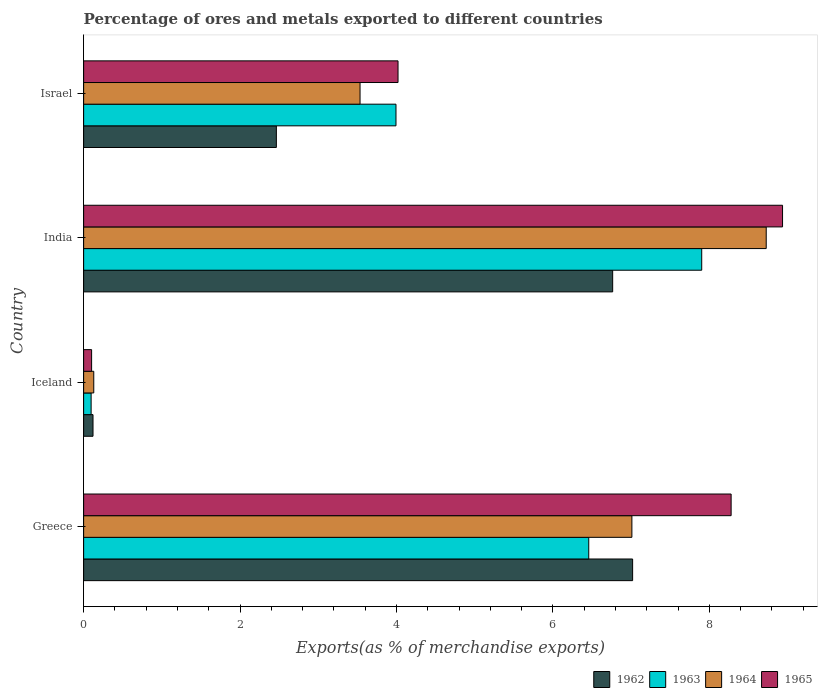Are the number of bars per tick equal to the number of legend labels?
Your answer should be very brief. Yes. Are the number of bars on each tick of the Y-axis equal?
Make the answer very short. Yes. What is the label of the 2nd group of bars from the top?
Offer a terse response. India. What is the percentage of exports to different countries in 1964 in Greece?
Give a very brief answer. 7.01. Across all countries, what is the maximum percentage of exports to different countries in 1962?
Your answer should be compact. 7.02. Across all countries, what is the minimum percentage of exports to different countries in 1964?
Keep it short and to the point. 0.13. In which country was the percentage of exports to different countries in 1962 maximum?
Offer a terse response. Greece. In which country was the percentage of exports to different countries in 1963 minimum?
Give a very brief answer. Iceland. What is the total percentage of exports to different countries in 1962 in the graph?
Give a very brief answer. 16.37. What is the difference between the percentage of exports to different countries in 1962 in Iceland and that in India?
Provide a short and direct response. -6.64. What is the difference between the percentage of exports to different countries in 1965 in India and the percentage of exports to different countries in 1964 in Greece?
Provide a short and direct response. 1.93. What is the average percentage of exports to different countries in 1964 per country?
Offer a terse response. 4.85. What is the difference between the percentage of exports to different countries in 1965 and percentage of exports to different countries in 1962 in Iceland?
Offer a terse response. -0.02. In how many countries, is the percentage of exports to different countries in 1964 greater than 5.6 %?
Keep it short and to the point. 2. What is the ratio of the percentage of exports to different countries in 1962 in India to that in Israel?
Your answer should be very brief. 2.75. Is the percentage of exports to different countries in 1962 in Iceland less than that in India?
Your answer should be compact. Yes. What is the difference between the highest and the second highest percentage of exports to different countries in 1964?
Ensure brevity in your answer.  1.72. What is the difference between the highest and the lowest percentage of exports to different countries in 1963?
Keep it short and to the point. 7.81. In how many countries, is the percentage of exports to different countries in 1965 greater than the average percentage of exports to different countries in 1965 taken over all countries?
Your answer should be very brief. 2. Is the sum of the percentage of exports to different countries in 1962 in Iceland and Israel greater than the maximum percentage of exports to different countries in 1963 across all countries?
Offer a terse response. No. Is it the case that in every country, the sum of the percentage of exports to different countries in 1962 and percentage of exports to different countries in 1963 is greater than the sum of percentage of exports to different countries in 1965 and percentage of exports to different countries in 1964?
Provide a succinct answer. No. What does the 4th bar from the top in Iceland represents?
Ensure brevity in your answer.  1962. What does the 4th bar from the bottom in Greece represents?
Your response must be concise. 1965. Is it the case that in every country, the sum of the percentage of exports to different countries in 1965 and percentage of exports to different countries in 1962 is greater than the percentage of exports to different countries in 1963?
Your answer should be very brief. Yes. Are all the bars in the graph horizontal?
Offer a very short reply. Yes. How many countries are there in the graph?
Keep it short and to the point. 4. What is the difference between two consecutive major ticks on the X-axis?
Your answer should be compact. 2. Does the graph contain any zero values?
Offer a terse response. No. Where does the legend appear in the graph?
Provide a short and direct response. Bottom right. How many legend labels are there?
Make the answer very short. 4. What is the title of the graph?
Your answer should be very brief. Percentage of ores and metals exported to different countries. What is the label or title of the X-axis?
Give a very brief answer. Exports(as % of merchandise exports). What is the Exports(as % of merchandise exports) of 1962 in Greece?
Offer a terse response. 7.02. What is the Exports(as % of merchandise exports) in 1963 in Greece?
Ensure brevity in your answer.  6.46. What is the Exports(as % of merchandise exports) in 1964 in Greece?
Your answer should be very brief. 7.01. What is the Exports(as % of merchandise exports) of 1965 in Greece?
Provide a succinct answer. 8.28. What is the Exports(as % of merchandise exports) of 1962 in Iceland?
Make the answer very short. 0.12. What is the Exports(as % of merchandise exports) in 1963 in Iceland?
Your answer should be very brief. 0.1. What is the Exports(as % of merchandise exports) in 1964 in Iceland?
Keep it short and to the point. 0.13. What is the Exports(as % of merchandise exports) of 1965 in Iceland?
Offer a terse response. 0.1. What is the Exports(as % of merchandise exports) of 1962 in India?
Make the answer very short. 6.76. What is the Exports(as % of merchandise exports) of 1963 in India?
Make the answer very short. 7.9. What is the Exports(as % of merchandise exports) of 1964 in India?
Your response must be concise. 8.73. What is the Exports(as % of merchandise exports) in 1965 in India?
Your answer should be compact. 8.94. What is the Exports(as % of merchandise exports) of 1962 in Israel?
Provide a succinct answer. 2.46. What is the Exports(as % of merchandise exports) in 1963 in Israel?
Make the answer very short. 3.99. What is the Exports(as % of merchandise exports) in 1964 in Israel?
Your answer should be compact. 3.53. What is the Exports(as % of merchandise exports) of 1965 in Israel?
Your response must be concise. 4.02. Across all countries, what is the maximum Exports(as % of merchandise exports) of 1962?
Ensure brevity in your answer.  7.02. Across all countries, what is the maximum Exports(as % of merchandise exports) of 1963?
Your answer should be compact. 7.9. Across all countries, what is the maximum Exports(as % of merchandise exports) in 1964?
Offer a terse response. 8.73. Across all countries, what is the maximum Exports(as % of merchandise exports) in 1965?
Provide a short and direct response. 8.94. Across all countries, what is the minimum Exports(as % of merchandise exports) in 1962?
Make the answer very short. 0.12. Across all countries, what is the minimum Exports(as % of merchandise exports) in 1963?
Provide a succinct answer. 0.1. Across all countries, what is the minimum Exports(as % of merchandise exports) in 1964?
Your response must be concise. 0.13. Across all countries, what is the minimum Exports(as % of merchandise exports) of 1965?
Provide a succinct answer. 0.1. What is the total Exports(as % of merchandise exports) in 1962 in the graph?
Ensure brevity in your answer.  16.37. What is the total Exports(as % of merchandise exports) in 1963 in the graph?
Ensure brevity in your answer.  18.45. What is the total Exports(as % of merchandise exports) in 1964 in the graph?
Ensure brevity in your answer.  19.4. What is the total Exports(as % of merchandise exports) of 1965 in the graph?
Provide a succinct answer. 21.34. What is the difference between the Exports(as % of merchandise exports) of 1962 in Greece and that in Iceland?
Give a very brief answer. 6.9. What is the difference between the Exports(as % of merchandise exports) of 1963 in Greece and that in Iceland?
Ensure brevity in your answer.  6.36. What is the difference between the Exports(as % of merchandise exports) in 1964 in Greece and that in Iceland?
Provide a short and direct response. 6.88. What is the difference between the Exports(as % of merchandise exports) of 1965 in Greece and that in Iceland?
Offer a terse response. 8.18. What is the difference between the Exports(as % of merchandise exports) of 1962 in Greece and that in India?
Keep it short and to the point. 0.26. What is the difference between the Exports(as % of merchandise exports) of 1963 in Greece and that in India?
Your response must be concise. -1.44. What is the difference between the Exports(as % of merchandise exports) in 1964 in Greece and that in India?
Keep it short and to the point. -1.72. What is the difference between the Exports(as % of merchandise exports) of 1965 in Greece and that in India?
Make the answer very short. -0.66. What is the difference between the Exports(as % of merchandise exports) of 1962 in Greece and that in Israel?
Ensure brevity in your answer.  4.55. What is the difference between the Exports(as % of merchandise exports) of 1963 in Greece and that in Israel?
Ensure brevity in your answer.  2.46. What is the difference between the Exports(as % of merchandise exports) of 1964 in Greece and that in Israel?
Make the answer very short. 3.48. What is the difference between the Exports(as % of merchandise exports) of 1965 in Greece and that in Israel?
Offer a very short reply. 4.26. What is the difference between the Exports(as % of merchandise exports) in 1962 in Iceland and that in India?
Provide a short and direct response. -6.64. What is the difference between the Exports(as % of merchandise exports) of 1963 in Iceland and that in India?
Your response must be concise. -7.81. What is the difference between the Exports(as % of merchandise exports) in 1964 in Iceland and that in India?
Give a very brief answer. -8.6. What is the difference between the Exports(as % of merchandise exports) of 1965 in Iceland and that in India?
Keep it short and to the point. -8.83. What is the difference between the Exports(as % of merchandise exports) of 1962 in Iceland and that in Israel?
Give a very brief answer. -2.34. What is the difference between the Exports(as % of merchandise exports) in 1963 in Iceland and that in Israel?
Give a very brief answer. -3.9. What is the difference between the Exports(as % of merchandise exports) of 1964 in Iceland and that in Israel?
Your response must be concise. -3.4. What is the difference between the Exports(as % of merchandise exports) of 1965 in Iceland and that in Israel?
Your answer should be very brief. -3.92. What is the difference between the Exports(as % of merchandise exports) of 1962 in India and that in Israel?
Ensure brevity in your answer.  4.3. What is the difference between the Exports(as % of merchandise exports) in 1963 in India and that in Israel?
Offer a very short reply. 3.91. What is the difference between the Exports(as % of merchandise exports) in 1964 in India and that in Israel?
Your response must be concise. 5.19. What is the difference between the Exports(as % of merchandise exports) of 1965 in India and that in Israel?
Provide a short and direct response. 4.92. What is the difference between the Exports(as % of merchandise exports) of 1962 in Greece and the Exports(as % of merchandise exports) of 1963 in Iceland?
Your answer should be compact. 6.92. What is the difference between the Exports(as % of merchandise exports) in 1962 in Greece and the Exports(as % of merchandise exports) in 1964 in Iceland?
Provide a short and direct response. 6.89. What is the difference between the Exports(as % of merchandise exports) in 1962 in Greece and the Exports(as % of merchandise exports) in 1965 in Iceland?
Provide a short and direct response. 6.92. What is the difference between the Exports(as % of merchandise exports) in 1963 in Greece and the Exports(as % of merchandise exports) in 1964 in Iceland?
Ensure brevity in your answer.  6.33. What is the difference between the Exports(as % of merchandise exports) of 1963 in Greece and the Exports(as % of merchandise exports) of 1965 in Iceland?
Your response must be concise. 6.36. What is the difference between the Exports(as % of merchandise exports) in 1964 in Greece and the Exports(as % of merchandise exports) in 1965 in Iceland?
Your response must be concise. 6.91. What is the difference between the Exports(as % of merchandise exports) in 1962 in Greece and the Exports(as % of merchandise exports) in 1963 in India?
Your answer should be very brief. -0.88. What is the difference between the Exports(as % of merchandise exports) of 1962 in Greece and the Exports(as % of merchandise exports) of 1964 in India?
Keep it short and to the point. -1.71. What is the difference between the Exports(as % of merchandise exports) in 1962 in Greece and the Exports(as % of merchandise exports) in 1965 in India?
Provide a succinct answer. -1.92. What is the difference between the Exports(as % of merchandise exports) in 1963 in Greece and the Exports(as % of merchandise exports) in 1964 in India?
Keep it short and to the point. -2.27. What is the difference between the Exports(as % of merchandise exports) of 1963 in Greece and the Exports(as % of merchandise exports) of 1965 in India?
Offer a terse response. -2.48. What is the difference between the Exports(as % of merchandise exports) in 1964 in Greece and the Exports(as % of merchandise exports) in 1965 in India?
Your answer should be compact. -1.93. What is the difference between the Exports(as % of merchandise exports) of 1962 in Greece and the Exports(as % of merchandise exports) of 1963 in Israel?
Offer a terse response. 3.03. What is the difference between the Exports(as % of merchandise exports) in 1962 in Greece and the Exports(as % of merchandise exports) in 1964 in Israel?
Keep it short and to the point. 3.48. What is the difference between the Exports(as % of merchandise exports) of 1962 in Greece and the Exports(as % of merchandise exports) of 1965 in Israel?
Your answer should be compact. 3. What is the difference between the Exports(as % of merchandise exports) of 1963 in Greece and the Exports(as % of merchandise exports) of 1964 in Israel?
Keep it short and to the point. 2.92. What is the difference between the Exports(as % of merchandise exports) of 1963 in Greece and the Exports(as % of merchandise exports) of 1965 in Israel?
Your answer should be compact. 2.44. What is the difference between the Exports(as % of merchandise exports) of 1964 in Greece and the Exports(as % of merchandise exports) of 1965 in Israel?
Make the answer very short. 2.99. What is the difference between the Exports(as % of merchandise exports) in 1962 in Iceland and the Exports(as % of merchandise exports) in 1963 in India?
Make the answer very short. -7.78. What is the difference between the Exports(as % of merchandise exports) of 1962 in Iceland and the Exports(as % of merchandise exports) of 1964 in India?
Provide a succinct answer. -8.61. What is the difference between the Exports(as % of merchandise exports) in 1962 in Iceland and the Exports(as % of merchandise exports) in 1965 in India?
Give a very brief answer. -8.82. What is the difference between the Exports(as % of merchandise exports) in 1963 in Iceland and the Exports(as % of merchandise exports) in 1964 in India?
Provide a succinct answer. -8.63. What is the difference between the Exports(as % of merchandise exports) in 1963 in Iceland and the Exports(as % of merchandise exports) in 1965 in India?
Ensure brevity in your answer.  -8.84. What is the difference between the Exports(as % of merchandise exports) in 1964 in Iceland and the Exports(as % of merchandise exports) in 1965 in India?
Your response must be concise. -8.81. What is the difference between the Exports(as % of merchandise exports) of 1962 in Iceland and the Exports(as % of merchandise exports) of 1963 in Israel?
Keep it short and to the point. -3.87. What is the difference between the Exports(as % of merchandise exports) of 1962 in Iceland and the Exports(as % of merchandise exports) of 1964 in Israel?
Ensure brevity in your answer.  -3.41. What is the difference between the Exports(as % of merchandise exports) of 1962 in Iceland and the Exports(as % of merchandise exports) of 1965 in Israel?
Keep it short and to the point. -3.9. What is the difference between the Exports(as % of merchandise exports) of 1963 in Iceland and the Exports(as % of merchandise exports) of 1964 in Israel?
Provide a succinct answer. -3.44. What is the difference between the Exports(as % of merchandise exports) in 1963 in Iceland and the Exports(as % of merchandise exports) in 1965 in Israel?
Offer a terse response. -3.92. What is the difference between the Exports(as % of merchandise exports) of 1964 in Iceland and the Exports(as % of merchandise exports) of 1965 in Israel?
Give a very brief answer. -3.89. What is the difference between the Exports(as % of merchandise exports) in 1962 in India and the Exports(as % of merchandise exports) in 1963 in Israel?
Ensure brevity in your answer.  2.77. What is the difference between the Exports(as % of merchandise exports) of 1962 in India and the Exports(as % of merchandise exports) of 1964 in Israel?
Make the answer very short. 3.23. What is the difference between the Exports(as % of merchandise exports) in 1962 in India and the Exports(as % of merchandise exports) in 1965 in Israel?
Provide a succinct answer. 2.74. What is the difference between the Exports(as % of merchandise exports) in 1963 in India and the Exports(as % of merchandise exports) in 1964 in Israel?
Your answer should be very brief. 4.37. What is the difference between the Exports(as % of merchandise exports) of 1963 in India and the Exports(as % of merchandise exports) of 1965 in Israel?
Keep it short and to the point. 3.88. What is the difference between the Exports(as % of merchandise exports) of 1964 in India and the Exports(as % of merchandise exports) of 1965 in Israel?
Offer a terse response. 4.71. What is the average Exports(as % of merchandise exports) of 1962 per country?
Provide a succinct answer. 4.09. What is the average Exports(as % of merchandise exports) in 1963 per country?
Give a very brief answer. 4.61. What is the average Exports(as % of merchandise exports) of 1964 per country?
Offer a terse response. 4.85. What is the average Exports(as % of merchandise exports) in 1965 per country?
Your response must be concise. 5.33. What is the difference between the Exports(as % of merchandise exports) in 1962 and Exports(as % of merchandise exports) in 1963 in Greece?
Your answer should be compact. 0.56. What is the difference between the Exports(as % of merchandise exports) of 1962 and Exports(as % of merchandise exports) of 1964 in Greece?
Provide a short and direct response. 0.01. What is the difference between the Exports(as % of merchandise exports) of 1962 and Exports(as % of merchandise exports) of 1965 in Greece?
Provide a succinct answer. -1.26. What is the difference between the Exports(as % of merchandise exports) in 1963 and Exports(as % of merchandise exports) in 1964 in Greece?
Give a very brief answer. -0.55. What is the difference between the Exports(as % of merchandise exports) in 1963 and Exports(as % of merchandise exports) in 1965 in Greece?
Provide a short and direct response. -1.82. What is the difference between the Exports(as % of merchandise exports) of 1964 and Exports(as % of merchandise exports) of 1965 in Greece?
Offer a terse response. -1.27. What is the difference between the Exports(as % of merchandise exports) of 1962 and Exports(as % of merchandise exports) of 1963 in Iceland?
Provide a short and direct response. 0.02. What is the difference between the Exports(as % of merchandise exports) in 1962 and Exports(as % of merchandise exports) in 1964 in Iceland?
Your answer should be very brief. -0.01. What is the difference between the Exports(as % of merchandise exports) in 1962 and Exports(as % of merchandise exports) in 1965 in Iceland?
Provide a succinct answer. 0.02. What is the difference between the Exports(as % of merchandise exports) in 1963 and Exports(as % of merchandise exports) in 1964 in Iceland?
Offer a terse response. -0.03. What is the difference between the Exports(as % of merchandise exports) of 1963 and Exports(as % of merchandise exports) of 1965 in Iceland?
Keep it short and to the point. -0.01. What is the difference between the Exports(as % of merchandise exports) of 1964 and Exports(as % of merchandise exports) of 1965 in Iceland?
Your response must be concise. 0.03. What is the difference between the Exports(as % of merchandise exports) of 1962 and Exports(as % of merchandise exports) of 1963 in India?
Keep it short and to the point. -1.14. What is the difference between the Exports(as % of merchandise exports) of 1962 and Exports(as % of merchandise exports) of 1964 in India?
Your response must be concise. -1.96. What is the difference between the Exports(as % of merchandise exports) of 1962 and Exports(as % of merchandise exports) of 1965 in India?
Offer a very short reply. -2.17. What is the difference between the Exports(as % of merchandise exports) of 1963 and Exports(as % of merchandise exports) of 1964 in India?
Ensure brevity in your answer.  -0.82. What is the difference between the Exports(as % of merchandise exports) in 1963 and Exports(as % of merchandise exports) in 1965 in India?
Provide a succinct answer. -1.03. What is the difference between the Exports(as % of merchandise exports) in 1964 and Exports(as % of merchandise exports) in 1965 in India?
Your answer should be very brief. -0.21. What is the difference between the Exports(as % of merchandise exports) of 1962 and Exports(as % of merchandise exports) of 1963 in Israel?
Provide a short and direct response. -1.53. What is the difference between the Exports(as % of merchandise exports) of 1962 and Exports(as % of merchandise exports) of 1964 in Israel?
Keep it short and to the point. -1.07. What is the difference between the Exports(as % of merchandise exports) of 1962 and Exports(as % of merchandise exports) of 1965 in Israel?
Give a very brief answer. -1.56. What is the difference between the Exports(as % of merchandise exports) in 1963 and Exports(as % of merchandise exports) in 1964 in Israel?
Your answer should be compact. 0.46. What is the difference between the Exports(as % of merchandise exports) of 1963 and Exports(as % of merchandise exports) of 1965 in Israel?
Provide a short and direct response. -0.03. What is the difference between the Exports(as % of merchandise exports) in 1964 and Exports(as % of merchandise exports) in 1965 in Israel?
Your response must be concise. -0.49. What is the ratio of the Exports(as % of merchandise exports) of 1962 in Greece to that in Iceland?
Your answer should be compact. 58.51. What is the ratio of the Exports(as % of merchandise exports) in 1963 in Greece to that in Iceland?
Your response must be concise. 67.38. What is the ratio of the Exports(as % of merchandise exports) of 1964 in Greece to that in Iceland?
Your response must be concise. 54.09. What is the ratio of the Exports(as % of merchandise exports) in 1965 in Greece to that in Iceland?
Your answer should be very brief. 81.09. What is the ratio of the Exports(as % of merchandise exports) in 1962 in Greece to that in India?
Ensure brevity in your answer.  1.04. What is the ratio of the Exports(as % of merchandise exports) of 1963 in Greece to that in India?
Provide a short and direct response. 0.82. What is the ratio of the Exports(as % of merchandise exports) of 1964 in Greece to that in India?
Your response must be concise. 0.8. What is the ratio of the Exports(as % of merchandise exports) in 1965 in Greece to that in India?
Your answer should be very brief. 0.93. What is the ratio of the Exports(as % of merchandise exports) in 1962 in Greece to that in Israel?
Your answer should be compact. 2.85. What is the ratio of the Exports(as % of merchandise exports) in 1963 in Greece to that in Israel?
Your response must be concise. 1.62. What is the ratio of the Exports(as % of merchandise exports) of 1964 in Greece to that in Israel?
Give a very brief answer. 1.98. What is the ratio of the Exports(as % of merchandise exports) of 1965 in Greece to that in Israel?
Provide a succinct answer. 2.06. What is the ratio of the Exports(as % of merchandise exports) in 1962 in Iceland to that in India?
Your response must be concise. 0.02. What is the ratio of the Exports(as % of merchandise exports) in 1963 in Iceland to that in India?
Give a very brief answer. 0.01. What is the ratio of the Exports(as % of merchandise exports) of 1964 in Iceland to that in India?
Your answer should be very brief. 0.01. What is the ratio of the Exports(as % of merchandise exports) in 1965 in Iceland to that in India?
Provide a short and direct response. 0.01. What is the ratio of the Exports(as % of merchandise exports) in 1962 in Iceland to that in Israel?
Keep it short and to the point. 0.05. What is the ratio of the Exports(as % of merchandise exports) of 1963 in Iceland to that in Israel?
Offer a terse response. 0.02. What is the ratio of the Exports(as % of merchandise exports) in 1964 in Iceland to that in Israel?
Your response must be concise. 0.04. What is the ratio of the Exports(as % of merchandise exports) in 1965 in Iceland to that in Israel?
Your answer should be very brief. 0.03. What is the ratio of the Exports(as % of merchandise exports) in 1962 in India to that in Israel?
Ensure brevity in your answer.  2.75. What is the ratio of the Exports(as % of merchandise exports) in 1963 in India to that in Israel?
Make the answer very short. 1.98. What is the ratio of the Exports(as % of merchandise exports) of 1964 in India to that in Israel?
Make the answer very short. 2.47. What is the ratio of the Exports(as % of merchandise exports) in 1965 in India to that in Israel?
Offer a terse response. 2.22. What is the difference between the highest and the second highest Exports(as % of merchandise exports) of 1962?
Provide a succinct answer. 0.26. What is the difference between the highest and the second highest Exports(as % of merchandise exports) in 1963?
Ensure brevity in your answer.  1.44. What is the difference between the highest and the second highest Exports(as % of merchandise exports) of 1964?
Provide a short and direct response. 1.72. What is the difference between the highest and the second highest Exports(as % of merchandise exports) in 1965?
Ensure brevity in your answer.  0.66. What is the difference between the highest and the lowest Exports(as % of merchandise exports) of 1962?
Offer a very short reply. 6.9. What is the difference between the highest and the lowest Exports(as % of merchandise exports) in 1963?
Offer a very short reply. 7.81. What is the difference between the highest and the lowest Exports(as % of merchandise exports) of 1964?
Give a very brief answer. 8.6. What is the difference between the highest and the lowest Exports(as % of merchandise exports) of 1965?
Your answer should be very brief. 8.83. 